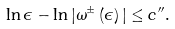Convert formula to latex. <formula><loc_0><loc_0><loc_500><loc_500>\ln \epsilon - \ln | \omega ^ { \pm } \left ( \epsilon \right ) | \leq c ^ { \prime \prime } .</formula> 